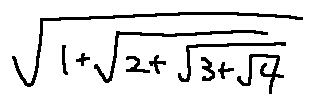<formula> <loc_0><loc_0><loc_500><loc_500>\sqrt { 1 + \sqrt { 2 + \sqrt { 3 + \sqrt { 4 } } } }</formula> 